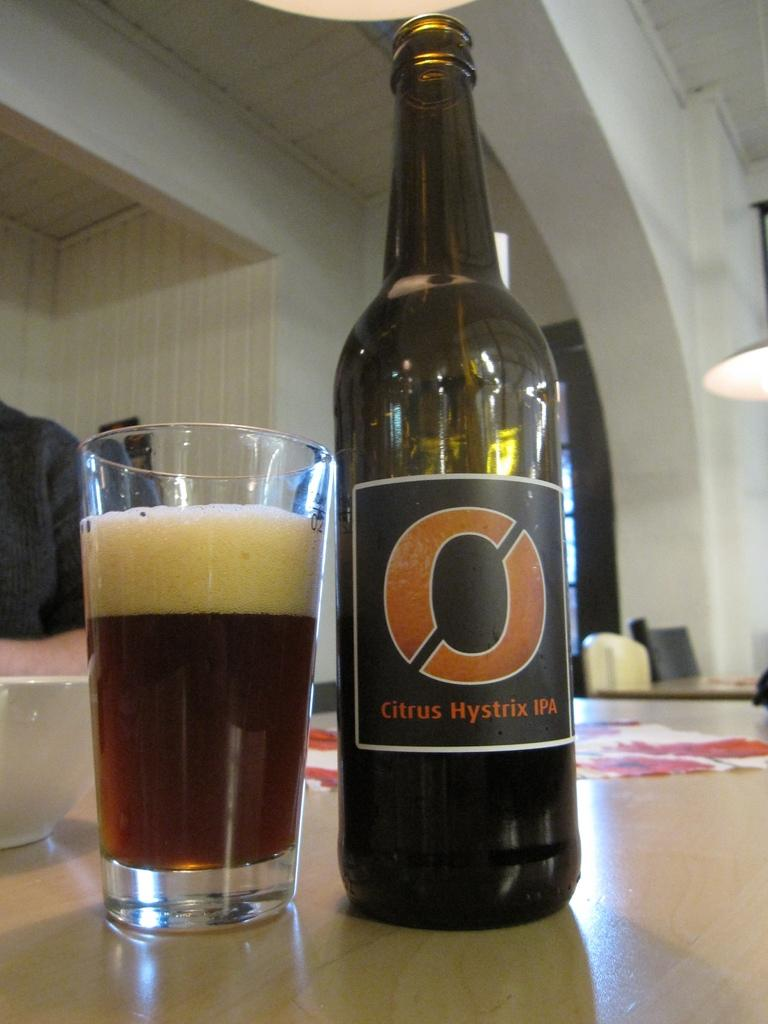<image>
Describe the image concisely. An amber colored bottle of a Citrus Hystrix IPA with black and orange label next to a nearly full glass. 